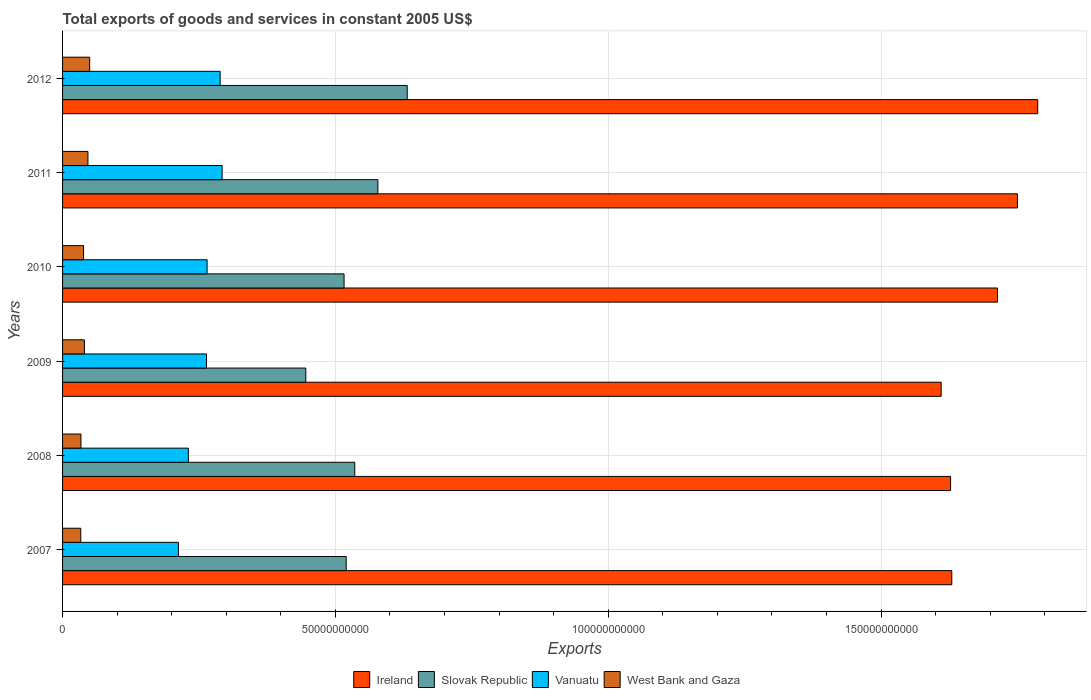How many different coloured bars are there?
Provide a short and direct response. 4. Are the number of bars per tick equal to the number of legend labels?
Offer a very short reply. Yes. How many bars are there on the 5th tick from the top?
Your answer should be compact. 4. How many bars are there on the 1st tick from the bottom?
Give a very brief answer. 4. What is the label of the 4th group of bars from the top?
Ensure brevity in your answer.  2009. In how many cases, is the number of bars for a given year not equal to the number of legend labels?
Your answer should be compact. 0. What is the total exports of goods and services in West Bank and Gaza in 2011?
Ensure brevity in your answer.  4.65e+09. Across all years, what is the maximum total exports of goods and services in Ireland?
Make the answer very short. 1.79e+11. Across all years, what is the minimum total exports of goods and services in Ireland?
Offer a very short reply. 1.61e+11. In which year was the total exports of goods and services in Slovak Republic maximum?
Provide a short and direct response. 2012. In which year was the total exports of goods and services in West Bank and Gaza minimum?
Provide a succinct answer. 2007. What is the total total exports of goods and services in Slovak Republic in the graph?
Keep it short and to the point. 3.23e+11. What is the difference between the total exports of goods and services in West Bank and Gaza in 2007 and that in 2012?
Your answer should be very brief. -1.63e+09. What is the difference between the total exports of goods and services in Ireland in 2008 and the total exports of goods and services in Slovak Republic in 2012?
Provide a short and direct response. 9.96e+1. What is the average total exports of goods and services in West Bank and Gaza per year?
Offer a very short reply. 4.03e+09. In the year 2012, what is the difference between the total exports of goods and services in West Bank and Gaza and total exports of goods and services in Ireland?
Your response must be concise. -1.74e+11. What is the ratio of the total exports of goods and services in Slovak Republic in 2007 to that in 2010?
Keep it short and to the point. 1.01. Is the difference between the total exports of goods and services in West Bank and Gaza in 2008 and 2011 greater than the difference between the total exports of goods and services in Ireland in 2008 and 2011?
Ensure brevity in your answer.  Yes. What is the difference between the highest and the second highest total exports of goods and services in West Bank and Gaza?
Offer a very short reply. 3.20e+08. What is the difference between the highest and the lowest total exports of goods and services in Slovak Republic?
Offer a very short reply. 1.86e+1. What does the 3rd bar from the top in 2012 represents?
Make the answer very short. Slovak Republic. What does the 1st bar from the bottom in 2011 represents?
Make the answer very short. Ireland. Is it the case that in every year, the sum of the total exports of goods and services in Vanuatu and total exports of goods and services in West Bank and Gaza is greater than the total exports of goods and services in Ireland?
Keep it short and to the point. No. Are all the bars in the graph horizontal?
Provide a short and direct response. Yes. How many years are there in the graph?
Provide a succinct answer. 6. What is the difference between two consecutive major ticks on the X-axis?
Provide a short and direct response. 5.00e+1. How many legend labels are there?
Provide a succinct answer. 4. What is the title of the graph?
Ensure brevity in your answer.  Total exports of goods and services in constant 2005 US$. Does "Sierra Leone" appear as one of the legend labels in the graph?
Your answer should be compact. No. What is the label or title of the X-axis?
Keep it short and to the point. Exports. What is the Exports in Ireland in 2007?
Provide a succinct answer. 1.63e+11. What is the Exports in Slovak Republic in 2007?
Your response must be concise. 5.20e+1. What is the Exports of Vanuatu in 2007?
Provide a succinct answer. 2.12e+1. What is the Exports in West Bank and Gaza in 2007?
Offer a terse response. 3.34e+09. What is the Exports in Ireland in 2008?
Ensure brevity in your answer.  1.63e+11. What is the Exports in Slovak Republic in 2008?
Give a very brief answer. 5.35e+1. What is the Exports of Vanuatu in 2008?
Offer a terse response. 2.31e+1. What is the Exports in West Bank and Gaza in 2008?
Your answer should be compact. 3.37e+09. What is the Exports in Ireland in 2009?
Give a very brief answer. 1.61e+11. What is the Exports of Slovak Republic in 2009?
Your response must be concise. 4.46e+1. What is the Exports in Vanuatu in 2009?
Your answer should be compact. 2.64e+1. What is the Exports in West Bank and Gaza in 2009?
Provide a succinct answer. 4.00e+09. What is the Exports of Ireland in 2010?
Make the answer very short. 1.71e+11. What is the Exports in Slovak Republic in 2010?
Give a very brief answer. 5.16e+1. What is the Exports of Vanuatu in 2010?
Your response must be concise. 2.65e+1. What is the Exports in West Bank and Gaza in 2010?
Provide a succinct answer. 3.85e+09. What is the Exports of Ireland in 2011?
Keep it short and to the point. 1.75e+11. What is the Exports of Slovak Republic in 2011?
Give a very brief answer. 5.78e+1. What is the Exports in Vanuatu in 2011?
Your answer should be compact. 2.92e+1. What is the Exports in West Bank and Gaza in 2011?
Make the answer very short. 4.65e+09. What is the Exports in Ireland in 2012?
Offer a terse response. 1.79e+11. What is the Exports in Slovak Republic in 2012?
Provide a succinct answer. 6.32e+1. What is the Exports of Vanuatu in 2012?
Offer a terse response. 2.89e+1. What is the Exports of West Bank and Gaza in 2012?
Your response must be concise. 4.97e+09. Across all years, what is the maximum Exports of Ireland?
Offer a terse response. 1.79e+11. Across all years, what is the maximum Exports of Slovak Republic?
Provide a short and direct response. 6.32e+1. Across all years, what is the maximum Exports in Vanuatu?
Make the answer very short. 2.92e+1. Across all years, what is the maximum Exports in West Bank and Gaza?
Offer a very short reply. 4.97e+09. Across all years, what is the minimum Exports in Ireland?
Offer a very short reply. 1.61e+11. Across all years, what is the minimum Exports of Slovak Republic?
Provide a short and direct response. 4.46e+1. Across all years, what is the minimum Exports of Vanuatu?
Your answer should be compact. 2.12e+1. Across all years, what is the minimum Exports in West Bank and Gaza?
Provide a short and direct response. 3.34e+09. What is the total Exports of Ireland in the graph?
Keep it short and to the point. 1.01e+12. What is the total Exports in Slovak Republic in the graph?
Your response must be concise. 3.23e+11. What is the total Exports in Vanuatu in the graph?
Keep it short and to the point. 1.55e+11. What is the total Exports in West Bank and Gaza in the graph?
Offer a terse response. 2.42e+1. What is the difference between the Exports of Ireland in 2007 and that in 2008?
Offer a very short reply. 2.20e+08. What is the difference between the Exports of Slovak Republic in 2007 and that in 2008?
Provide a short and direct response. -1.57e+09. What is the difference between the Exports of Vanuatu in 2007 and that in 2008?
Ensure brevity in your answer.  -1.83e+09. What is the difference between the Exports of West Bank and Gaza in 2007 and that in 2008?
Make the answer very short. -3.27e+07. What is the difference between the Exports of Ireland in 2007 and that in 2009?
Your answer should be compact. 1.95e+09. What is the difference between the Exports in Slovak Republic in 2007 and that in 2009?
Provide a short and direct response. 7.41e+09. What is the difference between the Exports of Vanuatu in 2007 and that in 2009?
Your answer should be compact. -5.15e+09. What is the difference between the Exports in West Bank and Gaza in 2007 and that in 2009?
Your answer should be very brief. -6.64e+08. What is the difference between the Exports in Ireland in 2007 and that in 2010?
Offer a very short reply. -8.38e+09. What is the difference between the Exports of Slovak Republic in 2007 and that in 2010?
Ensure brevity in your answer.  3.94e+08. What is the difference between the Exports in Vanuatu in 2007 and that in 2010?
Give a very brief answer. -5.26e+09. What is the difference between the Exports in West Bank and Gaza in 2007 and that in 2010?
Give a very brief answer. -5.13e+08. What is the difference between the Exports in Ireland in 2007 and that in 2011?
Offer a very short reply. -1.20e+1. What is the difference between the Exports of Slovak Republic in 2007 and that in 2011?
Your answer should be very brief. -5.80e+09. What is the difference between the Exports in Vanuatu in 2007 and that in 2011?
Your answer should be compact. -8.01e+09. What is the difference between the Exports in West Bank and Gaza in 2007 and that in 2011?
Your answer should be compact. -1.31e+09. What is the difference between the Exports in Ireland in 2007 and that in 2012?
Offer a terse response. -1.57e+1. What is the difference between the Exports of Slovak Republic in 2007 and that in 2012?
Keep it short and to the point. -1.12e+1. What is the difference between the Exports in Vanuatu in 2007 and that in 2012?
Your answer should be very brief. -7.65e+09. What is the difference between the Exports in West Bank and Gaza in 2007 and that in 2012?
Your answer should be very brief. -1.63e+09. What is the difference between the Exports of Ireland in 2008 and that in 2009?
Offer a very short reply. 1.73e+09. What is the difference between the Exports of Slovak Republic in 2008 and that in 2009?
Your response must be concise. 8.98e+09. What is the difference between the Exports in Vanuatu in 2008 and that in 2009?
Ensure brevity in your answer.  -3.32e+09. What is the difference between the Exports in West Bank and Gaza in 2008 and that in 2009?
Ensure brevity in your answer.  -6.32e+08. What is the difference between the Exports of Ireland in 2008 and that in 2010?
Make the answer very short. -8.60e+09. What is the difference between the Exports in Slovak Republic in 2008 and that in 2010?
Ensure brevity in your answer.  1.96e+09. What is the difference between the Exports of Vanuatu in 2008 and that in 2010?
Offer a terse response. -3.43e+09. What is the difference between the Exports in West Bank and Gaza in 2008 and that in 2010?
Provide a short and direct response. -4.80e+08. What is the difference between the Exports of Ireland in 2008 and that in 2011?
Provide a short and direct response. -1.22e+1. What is the difference between the Exports of Slovak Republic in 2008 and that in 2011?
Ensure brevity in your answer.  -4.23e+09. What is the difference between the Exports in Vanuatu in 2008 and that in 2011?
Keep it short and to the point. -6.19e+09. What is the difference between the Exports of West Bank and Gaza in 2008 and that in 2011?
Offer a terse response. -1.28e+09. What is the difference between the Exports in Ireland in 2008 and that in 2012?
Ensure brevity in your answer.  -1.60e+1. What is the difference between the Exports of Slovak Republic in 2008 and that in 2012?
Provide a succinct answer. -9.61e+09. What is the difference between the Exports of Vanuatu in 2008 and that in 2012?
Offer a very short reply. -5.82e+09. What is the difference between the Exports of West Bank and Gaza in 2008 and that in 2012?
Your answer should be compact. -1.60e+09. What is the difference between the Exports in Ireland in 2009 and that in 2010?
Provide a succinct answer. -1.03e+1. What is the difference between the Exports of Slovak Republic in 2009 and that in 2010?
Your answer should be very brief. -7.01e+09. What is the difference between the Exports in Vanuatu in 2009 and that in 2010?
Offer a very short reply. -1.09e+08. What is the difference between the Exports of West Bank and Gaza in 2009 and that in 2010?
Your response must be concise. 1.52e+08. What is the difference between the Exports of Ireland in 2009 and that in 2011?
Offer a very short reply. -1.40e+1. What is the difference between the Exports in Slovak Republic in 2009 and that in 2011?
Your response must be concise. -1.32e+1. What is the difference between the Exports in Vanuatu in 2009 and that in 2011?
Ensure brevity in your answer.  -2.86e+09. What is the difference between the Exports in West Bank and Gaza in 2009 and that in 2011?
Provide a succinct answer. -6.48e+08. What is the difference between the Exports in Ireland in 2009 and that in 2012?
Provide a short and direct response. -1.77e+1. What is the difference between the Exports in Slovak Republic in 2009 and that in 2012?
Keep it short and to the point. -1.86e+1. What is the difference between the Exports in Vanuatu in 2009 and that in 2012?
Keep it short and to the point. -2.50e+09. What is the difference between the Exports in West Bank and Gaza in 2009 and that in 2012?
Your answer should be very brief. -9.69e+08. What is the difference between the Exports in Ireland in 2010 and that in 2011?
Keep it short and to the point. -3.65e+09. What is the difference between the Exports in Slovak Republic in 2010 and that in 2011?
Keep it short and to the point. -6.19e+09. What is the difference between the Exports of Vanuatu in 2010 and that in 2011?
Provide a succinct answer. -2.76e+09. What is the difference between the Exports in West Bank and Gaza in 2010 and that in 2011?
Provide a succinct answer. -8.00e+08. What is the difference between the Exports of Ireland in 2010 and that in 2012?
Your response must be concise. -7.37e+09. What is the difference between the Exports in Slovak Republic in 2010 and that in 2012?
Offer a terse response. -1.16e+1. What is the difference between the Exports in Vanuatu in 2010 and that in 2012?
Ensure brevity in your answer.  -2.39e+09. What is the difference between the Exports of West Bank and Gaza in 2010 and that in 2012?
Make the answer very short. -1.12e+09. What is the difference between the Exports of Ireland in 2011 and that in 2012?
Offer a very short reply. -3.72e+09. What is the difference between the Exports of Slovak Republic in 2011 and that in 2012?
Give a very brief answer. -5.38e+09. What is the difference between the Exports of Vanuatu in 2011 and that in 2012?
Your answer should be very brief. 3.63e+08. What is the difference between the Exports in West Bank and Gaza in 2011 and that in 2012?
Your answer should be very brief. -3.20e+08. What is the difference between the Exports of Ireland in 2007 and the Exports of Slovak Republic in 2008?
Offer a terse response. 1.09e+11. What is the difference between the Exports of Ireland in 2007 and the Exports of Vanuatu in 2008?
Make the answer very short. 1.40e+11. What is the difference between the Exports in Ireland in 2007 and the Exports in West Bank and Gaza in 2008?
Provide a succinct answer. 1.60e+11. What is the difference between the Exports of Slovak Republic in 2007 and the Exports of Vanuatu in 2008?
Make the answer very short. 2.89e+1. What is the difference between the Exports of Slovak Republic in 2007 and the Exports of West Bank and Gaza in 2008?
Make the answer very short. 4.86e+1. What is the difference between the Exports of Vanuatu in 2007 and the Exports of West Bank and Gaza in 2008?
Ensure brevity in your answer.  1.79e+1. What is the difference between the Exports in Ireland in 2007 and the Exports in Slovak Republic in 2009?
Offer a very short reply. 1.18e+11. What is the difference between the Exports in Ireland in 2007 and the Exports in Vanuatu in 2009?
Offer a terse response. 1.37e+11. What is the difference between the Exports of Ireland in 2007 and the Exports of West Bank and Gaza in 2009?
Offer a terse response. 1.59e+11. What is the difference between the Exports of Slovak Republic in 2007 and the Exports of Vanuatu in 2009?
Your answer should be compact. 2.56e+1. What is the difference between the Exports in Slovak Republic in 2007 and the Exports in West Bank and Gaza in 2009?
Offer a very short reply. 4.80e+1. What is the difference between the Exports in Vanuatu in 2007 and the Exports in West Bank and Gaza in 2009?
Offer a terse response. 1.72e+1. What is the difference between the Exports of Ireland in 2007 and the Exports of Slovak Republic in 2010?
Provide a short and direct response. 1.11e+11. What is the difference between the Exports of Ireland in 2007 and the Exports of Vanuatu in 2010?
Offer a very short reply. 1.36e+11. What is the difference between the Exports in Ireland in 2007 and the Exports in West Bank and Gaza in 2010?
Your answer should be very brief. 1.59e+11. What is the difference between the Exports of Slovak Republic in 2007 and the Exports of Vanuatu in 2010?
Provide a short and direct response. 2.55e+1. What is the difference between the Exports in Slovak Republic in 2007 and the Exports in West Bank and Gaza in 2010?
Your response must be concise. 4.81e+1. What is the difference between the Exports of Vanuatu in 2007 and the Exports of West Bank and Gaza in 2010?
Provide a short and direct response. 1.74e+1. What is the difference between the Exports in Ireland in 2007 and the Exports in Slovak Republic in 2011?
Give a very brief answer. 1.05e+11. What is the difference between the Exports in Ireland in 2007 and the Exports in Vanuatu in 2011?
Give a very brief answer. 1.34e+11. What is the difference between the Exports of Ireland in 2007 and the Exports of West Bank and Gaza in 2011?
Keep it short and to the point. 1.58e+11. What is the difference between the Exports in Slovak Republic in 2007 and the Exports in Vanuatu in 2011?
Offer a terse response. 2.27e+1. What is the difference between the Exports in Slovak Republic in 2007 and the Exports in West Bank and Gaza in 2011?
Give a very brief answer. 4.73e+1. What is the difference between the Exports of Vanuatu in 2007 and the Exports of West Bank and Gaza in 2011?
Offer a terse response. 1.66e+1. What is the difference between the Exports in Ireland in 2007 and the Exports in Slovak Republic in 2012?
Offer a very short reply. 9.98e+1. What is the difference between the Exports in Ireland in 2007 and the Exports in Vanuatu in 2012?
Offer a terse response. 1.34e+11. What is the difference between the Exports of Ireland in 2007 and the Exports of West Bank and Gaza in 2012?
Ensure brevity in your answer.  1.58e+11. What is the difference between the Exports of Slovak Republic in 2007 and the Exports of Vanuatu in 2012?
Provide a succinct answer. 2.31e+1. What is the difference between the Exports of Slovak Republic in 2007 and the Exports of West Bank and Gaza in 2012?
Your answer should be compact. 4.70e+1. What is the difference between the Exports of Vanuatu in 2007 and the Exports of West Bank and Gaza in 2012?
Make the answer very short. 1.63e+1. What is the difference between the Exports in Ireland in 2008 and the Exports in Slovak Republic in 2009?
Offer a terse response. 1.18e+11. What is the difference between the Exports in Ireland in 2008 and the Exports in Vanuatu in 2009?
Your answer should be compact. 1.36e+11. What is the difference between the Exports of Ireland in 2008 and the Exports of West Bank and Gaza in 2009?
Offer a very short reply. 1.59e+11. What is the difference between the Exports of Slovak Republic in 2008 and the Exports of Vanuatu in 2009?
Ensure brevity in your answer.  2.72e+1. What is the difference between the Exports in Slovak Republic in 2008 and the Exports in West Bank and Gaza in 2009?
Offer a very short reply. 4.95e+1. What is the difference between the Exports in Vanuatu in 2008 and the Exports in West Bank and Gaza in 2009?
Provide a short and direct response. 1.91e+1. What is the difference between the Exports of Ireland in 2008 and the Exports of Slovak Republic in 2010?
Your response must be concise. 1.11e+11. What is the difference between the Exports of Ireland in 2008 and the Exports of Vanuatu in 2010?
Give a very brief answer. 1.36e+11. What is the difference between the Exports of Ireland in 2008 and the Exports of West Bank and Gaza in 2010?
Provide a succinct answer. 1.59e+11. What is the difference between the Exports of Slovak Republic in 2008 and the Exports of Vanuatu in 2010?
Your answer should be very brief. 2.71e+1. What is the difference between the Exports of Slovak Republic in 2008 and the Exports of West Bank and Gaza in 2010?
Offer a very short reply. 4.97e+1. What is the difference between the Exports in Vanuatu in 2008 and the Exports in West Bank and Gaza in 2010?
Provide a short and direct response. 1.92e+1. What is the difference between the Exports in Ireland in 2008 and the Exports in Slovak Republic in 2011?
Offer a terse response. 1.05e+11. What is the difference between the Exports of Ireland in 2008 and the Exports of Vanuatu in 2011?
Give a very brief answer. 1.33e+11. What is the difference between the Exports in Ireland in 2008 and the Exports in West Bank and Gaza in 2011?
Ensure brevity in your answer.  1.58e+11. What is the difference between the Exports in Slovak Republic in 2008 and the Exports in Vanuatu in 2011?
Offer a very short reply. 2.43e+1. What is the difference between the Exports of Slovak Republic in 2008 and the Exports of West Bank and Gaza in 2011?
Offer a very short reply. 4.89e+1. What is the difference between the Exports of Vanuatu in 2008 and the Exports of West Bank and Gaza in 2011?
Provide a short and direct response. 1.84e+1. What is the difference between the Exports of Ireland in 2008 and the Exports of Slovak Republic in 2012?
Your answer should be compact. 9.96e+1. What is the difference between the Exports of Ireland in 2008 and the Exports of Vanuatu in 2012?
Provide a short and direct response. 1.34e+11. What is the difference between the Exports in Ireland in 2008 and the Exports in West Bank and Gaza in 2012?
Your response must be concise. 1.58e+11. What is the difference between the Exports of Slovak Republic in 2008 and the Exports of Vanuatu in 2012?
Offer a terse response. 2.47e+1. What is the difference between the Exports of Slovak Republic in 2008 and the Exports of West Bank and Gaza in 2012?
Ensure brevity in your answer.  4.86e+1. What is the difference between the Exports of Vanuatu in 2008 and the Exports of West Bank and Gaza in 2012?
Offer a very short reply. 1.81e+1. What is the difference between the Exports in Ireland in 2009 and the Exports in Slovak Republic in 2010?
Offer a terse response. 1.09e+11. What is the difference between the Exports in Ireland in 2009 and the Exports in Vanuatu in 2010?
Ensure brevity in your answer.  1.35e+11. What is the difference between the Exports in Ireland in 2009 and the Exports in West Bank and Gaza in 2010?
Give a very brief answer. 1.57e+11. What is the difference between the Exports in Slovak Republic in 2009 and the Exports in Vanuatu in 2010?
Provide a short and direct response. 1.81e+1. What is the difference between the Exports of Slovak Republic in 2009 and the Exports of West Bank and Gaza in 2010?
Give a very brief answer. 4.07e+1. What is the difference between the Exports of Vanuatu in 2009 and the Exports of West Bank and Gaza in 2010?
Provide a succinct answer. 2.25e+1. What is the difference between the Exports in Ireland in 2009 and the Exports in Slovak Republic in 2011?
Make the answer very short. 1.03e+11. What is the difference between the Exports in Ireland in 2009 and the Exports in Vanuatu in 2011?
Your answer should be compact. 1.32e+11. What is the difference between the Exports of Ireland in 2009 and the Exports of West Bank and Gaza in 2011?
Provide a succinct answer. 1.56e+11. What is the difference between the Exports in Slovak Republic in 2009 and the Exports in Vanuatu in 2011?
Give a very brief answer. 1.53e+1. What is the difference between the Exports of Slovak Republic in 2009 and the Exports of West Bank and Gaza in 2011?
Offer a very short reply. 3.99e+1. What is the difference between the Exports of Vanuatu in 2009 and the Exports of West Bank and Gaza in 2011?
Your answer should be compact. 2.17e+1. What is the difference between the Exports in Ireland in 2009 and the Exports in Slovak Republic in 2012?
Offer a terse response. 9.78e+1. What is the difference between the Exports in Ireland in 2009 and the Exports in Vanuatu in 2012?
Keep it short and to the point. 1.32e+11. What is the difference between the Exports in Ireland in 2009 and the Exports in West Bank and Gaza in 2012?
Offer a terse response. 1.56e+11. What is the difference between the Exports of Slovak Republic in 2009 and the Exports of Vanuatu in 2012?
Your answer should be compact. 1.57e+1. What is the difference between the Exports of Slovak Republic in 2009 and the Exports of West Bank and Gaza in 2012?
Provide a succinct answer. 3.96e+1. What is the difference between the Exports of Vanuatu in 2009 and the Exports of West Bank and Gaza in 2012?
Keep it short and to the point. 2.14e+1. What is the difference between the Exports in Ireland in 2010 and the Exports in Slovak Republic in 2011?
Make the answer very short. 1.14e+11. What is the difference between the Exports in Ireland in 2010 and the Exports in Vanuatu in 2011?
Your answer should be compact. 1.42e+11. What is the difference between the Exports of Ireland in 2010 and the Exports of West Bank and Gaza in 2011?
Your answer should be compact. 1.67e+11. What is the difference between the Exports of Slovak Republic in 2010 and the Exports of Vanuatu in 2011?
Offer a terse response. 2.23e+1. What is the difference between the Exports of Slovak Republic in 2010 and the Exports of West Bank and Gaza in 2011?
Offer a very short reply. 4.69e+1. What is the difference between the Exports of Vanuatu in 2010 and the Exports of West Bank and Gaza in 2011?
Ensure brevity in your answer.  2.18e+1. What is the difference between the Exports of Ireland in 2010 and the Exports of Slovak Republic in 2012?
Provide a succinct answer. 1.08e+11. What is the difference between the Exports in Ireland in 2010 and the Exports in Vanuatu in 2012?
Keep it short and to the point. 1.42e+11. What is the difference between the Exports in Ireland in 2010 and the Exports in West Bank and Gaza in 2012?
Your answer should be very brief. 1.66e+11. What is the difference between the Exports in Slovak Republic in 2010 and the Exports in Vanuatu in 2012?
Your answer should be very brief. 2.27e+1. What is the difference between the Exports of Slovak Republic in 2010 and the Exports of West Bank and Gaza in 2012?
Make the answer very short. 4.66e+1. What is the difference between the Exports of Vanuatu in 2010 and the Exports of West Bank and Gaza in 2012?
Your answer should be very brief. 2.15e+1. What is the difference between the Exports of Ireland in 2011 and the Exports of Slovak Republic in 2012?
Offer a very short reply. 1.12e+11. What is the difference between the Exports in Ireland in 2011 and the Exports in Vanuatu in 2012?
Your answer should be very brief. 1.46e+11. What is the difference between the Exports in Ireland in 2011 and the Exports in West Bank and Gaza in 2012?
Give a very brief answer. 1.70e+11. What is the difference between the Exports in Slovak Republic in 2011 and the Exports in Vanuatu in 2012?
Ensure brevity in your answer.  2.89e+1. What is the difference between the Exports of Slovak Republic in 2011 and the Exports of West Bank and Gaza in 2012?
Offer a very short reply. 5.28e+1. What is the difference between the Exports of Vanuatu in 2011 and the Exports of West Bank and Gaza in 2012?
Your answer should be very brief. 2.43e+1. What is the average Exports of Ireland per year?
Offer a terse response. 1.69e+11. What is the average Exports in Slovak Republic per year?
Offer a very short reply. 5.38e+1. What is the average Exports in Vanuatu per year?
Offer a very short reply. 2.59e+1. What is the average Exports in West Bank and Gaza per year?
Your answer should be compact. 4.03e+09. In the year 2007, what is the difference between the Exports in Ireland and Exports in Slovak Republic?
Your response must be concise. 1.11e+11. In the year 2007, what is the difference between the Exports in Ireland and Exports in Vanuatu?
Your response must be concise. 1.42e+11. In the year 2007, what is the difference between the Exports in Ireland and Exports in West Bank and Gaza?
Ensure brevity in your answer.  1.60e+11. In the year 2007, what is the difference between the Exports in Slovak Republic and Exports in Vanuatu?
Keep it short and to the point. 3.08e+1. In the year 2007, what is the difference between the Exports in Slovak Republic and Exports in West Bank and Gaza?
Ensure brevity in your answer.  4.86e+1. In the year 2007, what is the difference between the Exports in Vanuatu and Exports in West Bank and Gaza?
Your response must be concise. 1.79e+1. In the year 2008, what is the difference between the Exports in Ireland and Exports in Slovak Republic?
Keep it short and to the point. 1.09e+11. In the year 2008, what is the difference between the Exports in Ireland and Exports in Vanuatu?
Provide a succinct answer. 1.40e+11. In the year 2008, what is the difference between the Exports of Ireland and Exports of West Bank and Gaza?
Ensure brevity in your answer.  1.59e+11. In the year 2008, what is the difference between the Exports of Slovak Republic and Exports of Vanuatu?
Provide a short and direct response. 3.05e+1. In the year 2008, what is the difference between the Exports in Slovak Republic and Exports in West Bank and Gaza?
Give a very brief answer. 5.02e+1. In the year 2008, what is the difference between the Exports in Vanuatu and Exports in West Bank and Gaza?
Provide a succinct answer. 1.97e+1. In the year 2009, what is the difference between the Exports of Ireland and Exports of Slovak Republic?
Make the answer very short. 1.16e+11. In the year 2009, what is the difference between the Exports of Ireland and Exports of Vanuatu?
Keep it short and to the point. 1.35e+11. In the year 2009, what is the difference between the Exports of Ireland and Exports of West Bank and Gaza?
Provide a short and direct response. 1.57e+11. In the year 2009, what is the difference between the Exports of Slovak Republic and Exports of Vanuatu?
Your response must be concise. 1.82e+1. In the year 2009, what is the difference between the Exports of Slovak Republic and Exports of West Bank and Gaza?
Provide a short and direct response. 4.06e+1. In the year 2009, what is the difference between the Exports of Vanuatu and Exports of West Bank and Gaza?
Your answer should be compact. 2.24e+1. In the year 2010, what is the difference between the Exports of Ireland and Exports of Slovak Republic?
Ensure brevity in your answer.  1.20e+11. In the year 2010, what is the difference between the Exports of Ireland and Exports of Vanuatu?
Provide a short and direct response. 1.45e+11. In the year 2010, what is the difference between the Exports of Ireland and Exports of West Bank and Gaza?
Ensure brevity in your answer.  1.67e+11. In the year 2010, what is the difference between the Exports in Slovak Republic and Exports in Vanuatu?
Your response must be concise. 2.51e+1. In the year 2010, what is the difference between the Exports of Slovak Republic and Exports of West Bank and Gaza?
Offer a very short reply. 4.77e+1. In the year 2010, what is the difference between the Exports of Vanuatu and Exports of West Bank and Gaza?
Make the answer very short. 2.26e+1. In the year 2011, what is the difference between the Exports of Ireland and Exports of Slovak Republic?
Your answer should be compact. 1.17e+11. In the year 2011, what is the difference between the Exports of Ireland and Exports of Vanuatu?
Your answer should be very brief. 1.46e+11. In the year 2011, what is the difference between the Exports of Ireland and Exports of West Bank and Gaza?
Ensure brevity in your answer.  1.70e+11. In the year 2011, what is the difference between the Exports in Slovak Republic and Exports in Vanuatu?
Offer a very short reply. 2.85e+1. In the year 2011, what is the difference between the Exports of Slovak Republic and Exports of West Bank and Gaza?
Offer a very short reply. 5.31e+1. In the year 2011, what is the difference between the Exports in Vanuatu and Exports in West Bank and Gaza?
Your answer should be very brief. 2.46e+1. In the year 2012, what is the difference between the Exports in Ireland and Exports in Slovak Republic?
Ensure brevity in your answer.  1.16e+11. In the year 2012, what is the difference between the Exports in Ireland and Exports in Vanuatu?
Your answer should be very brief. 1.50e+11. In the year 2012, what is the difference between the Exports of Ireland and Exports of West Bank and Gaza?
Your answer should be compact. 1.74e+11. In the year 2012, what is the difference between the Exports in Slovak Republic and Exports in Vanuatu?
Ensure brevity in your answer.  3.43e+1. In the year 2012, what is the difference between the Exports of Slovak Republic and Exports of West Bank and Gaza?
Offer a very short reply. 5.82e+1. In the year 2012, what is the difference between the Exports in Vanuatu and Exports in West Bank and Gaza?
Keep it short and to the point. 2.39e+1. What is the ratio of the Exports in Slovak Republic in 2007 to that in 2008?
Offer a terse response. 0.97. What is the ratio of the Exports in Vanuatu in 2007 to that in 2008?
Give a very brief answer. 0.92. What is the ratio of the Exports of West Bank and Gaza in 2007 to that in 2008?
Give a very brief answer. 0.99. What is the ratio of the Exports in Ireland in 2007 to that in 2009?
Provide a succinct answer. 1.01. What is the ratio of the Exports in Slovak Republic in 2007 to that in 2009?
Keep it short and to the point. 1.17. What is the ratio of the Exports in Vanuatu in 2007 to that in 2009?
Your answer should be very brief. 0.8. What is the ratio of the Exports of West Bank and Gaza in 2007 to that in 2009?
Provide a succinct answer. 0.83. What is the ratio of the Exports in Ireland in 2007 to that in 2010?
Ensure brevity in your answer.  0.95. What is the ratio of the Exports of Slovak Republic in 2007 to that in 2010?
Offer a terse response. 1.01. What is the ratio of the Exports of Vanuatu in 2007 to that in 2010?
Ensure brevity in your answer.  0.8. What is the ratio of the Exports of West Bank and Gaza in 2007 to that in 2010?
Your answer should be very brief. 0.87. What is the ratio of the Exports in Ireland in 2007 to that in 2011?
Offer a terse response. 0.93. What is the ratio of the Exports of Slovak Republic in 2007 to that in 2011?
Offer a terse response. 0.9. What is the ratio of the Exports in Vanuatu in 2007 to that in 2011?
Your response must be concise. 0.73. What is the ratio of the Exports in West Bank and Gaza in 2007 to that in 2011?
Give a very brief answer. 0.72. What is the ratio of the Exports in Ireland in 2007 to that in 2012?
Your answer should be very brief. 0.91. What is the ratio of the Exports in Slovak Republic in 2007 to that in 2012?
Your answer should be very brief. 0.82. What is the ratio of the Exports of Vanuatu in 2007 to that in 2012?
Offer a terse response. 0.73. What is the ratio of the Exports in West Bank and Gaza in 2007 to that in 2012?
Keep it short and to the point. 0.67. What is the ratio of the Exports in Ireland in 2008 to that in 2009?
Give a very brief answer. 1.01. What is the ratio of the Exports in Slovak Republic in 2008 to that in 2009?
Your answer should be compact. 1.2. What is the ratio of the Exports of Vanuatu in 2008 to that in 2009?
Ensure brevity in your answer.  0.87. What is the ratio of the Exports of West Bank and Gaza in 2008 to that in 2009?
Provide a succinct answer. 0.84. What is the ratio of the Exports of Ireland in 2008 to that in 2010?
Keep it short and to the point. 0.95. What is the ratio of the Exports of Slovak Republic in 2008 to that in 2010?
Make the answer very short. 1.04. What is the ratio of the Exports in Vanuatu in 2008 to that in 2010?
Give a very brief answer. 0.87. What is the ratio of the Exports in West Bank and Gaza in 2008 to that in 2010?
Provide a succinct answer. 0.88. What is the ratio of the Exports in Ireland in 2008 to that in 2011?
Keep it short and to the point. 0.93. What is the ratio of the Exports in Slovak Republic in 2008 to that in 2011?
Make the answer very short. 0.93. What is the ratio of the Exports of Vanuatu in 2008 to that in 2011?
Give a very brief answer. 0.79. What is the ratio of the Exports in West Bank and Gaza in 2008 to that in 2011?
Your response must be concise. 0.72. What is the ratio of the Exports in Ireland in 2008 to that in 2012?
Ensure brevity in your answer.  0.91. What is the ratio of the Exports in Slovak Republic in 2008 to that in 2012?
Provide a short and direct response. 0.85. What is the ratio of the Exports in Vanuatu in 2008 to that in 2012?
Your response must be concise. 0.8. What is the ratio of the Exports in West Bank and Gaza in 2008 to that in 2012?
Your answer should be very brief. 0.68. What is the ratio of the Exports of Ireland in 2009 to that in 2010?
Keep it short and to the point. 0.94. What is the ratio of the Exports in Slovak Republic in 2009 to that in 2010?
Your answer should be compact. 0.86. What is the ratio of the Exports in Vanuatu in 2009 to that in 2010?
Ensure brevity in your answer.  1. What is the ratio of the Exports in West Bank and Gaza in 2009 to that in 2010?
Ensure brevity in your answer.  1.04. What is the ratio of the Exports of Ireland in 2009 to that in 2011?
Offer a terse response. 0.92. What is the ratio of the Exports of Slovak Republic in 2009 to that in 2011?
Your answer should be compact. 0.77. What is the ratio of the Exports of Vanuatu in 2009 to that in 2011?
Provide a short and direct response. 0.9. What is the ratio of the Exports in West Bank and Gaza in 2009 to that in 2011?
Offer a very short reply. 0.86. What is the ratio of the Exports of Ireland in 2009 to that in 2012?
Ensure brevity in your answer.  0.9. What is the ratio of the Exports in Slovak Republic in 2009 to that in 2012?
Your response must be concise. 0.71. What is the ratio of the Exports in Vanuatu in 2009 to that in 2012?
Ensure brevity in your answer.  0.91. What is the ratio of the Exports of West Bank and Gaza in 2009 to that in 2012?
Your answer should be compact. 0.81. What is the ratio of the Exports in Ireland in 2010 to that in 2011?
Ensure brevity in your answer.  0.98. What is the ratio of the Exports in Slovak Republic in 2010 to that in 2011?
Your answer should be compact. 0.89. What is the ratio of the Exports in Vanuatu in 2010 to that in 2011?
Your response must be concise. 0.91. What is the ratio of the Exports of West Bank and Gaza in 2010 to that in 2011?
Keep it short and to the point. 0.83. What is the ratio of the Exports in Ireland in 2010 to that in 2012?
Your answer should be compact. 0.96. What is the ratio of the Exports in Slovak Republic in 2010 to that in 2012?
Your answer should be very brief. 0.82. What is the ratio of the Exports of Vanuatu in 2010 to that in 2012?
Make the answer very short. 0.92. What is the ratio of the Exports in West Bank and Gaza in 2010 to that in 2012?
Your answer should be very brief. 0.77. What is the ratio of the Exports of Ireland in 2011 to that in 2012?
Provide a succinct answer. 0.98. What is the ratio of the Exports in Slovak Republic in 2011 to that in 2012?
Provide a succinct answer. 0.91. What is the ratio of the Exports in Vanuatu in 2011 to that in 2012?
Offer a terse response. 1.01. What is the ratio of the Exports in West Bank and Gaza in 2011 to that in 2012?
Ensure brevity in your answer.  0.94. What is the difference between the highest and the second highest Exports in Ireland?
Make the answer very short. 3.72e+09. What is the difference between the highest and the second highest Exports in Slovak Republic?
Offer a very short reply. 5.38e+09. What is the difference between the highest and the second highest Exports in Vanuatu?
Give a very brief answer. 3.63e+08. What is the difference between the highest and the second highest Exports in West Bank and Gaza?
Ensure brevity in your answer.  3.20e+08. What is the difference between the highest and the lowest Exports of Ireland?
Provide a short and direct response. 1.77e+1. What is the difference between the highest and the lowest Exports of Slovak Republic?
Keep it short and to the point. 1.86e+1. What is the difference between the highest and the lowest Exports in Vanuatu?
Provide a short and direct response. 8.01e+09. What is the difference between the highest and the lowest Exports of West Bank and Gaza?
Offer a terse response. 1.63e+09. 